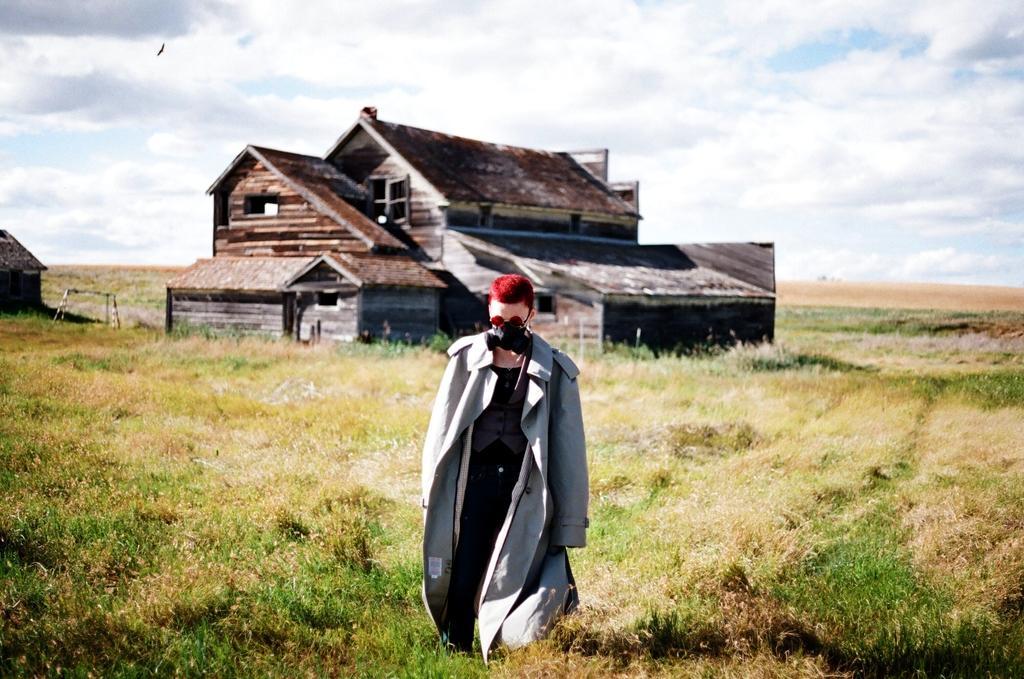Please provide a concise description of this image. In this image in front there is a person. At the bottom of the image there is grass on the surface. In the background of the image there are buildings and sky. 